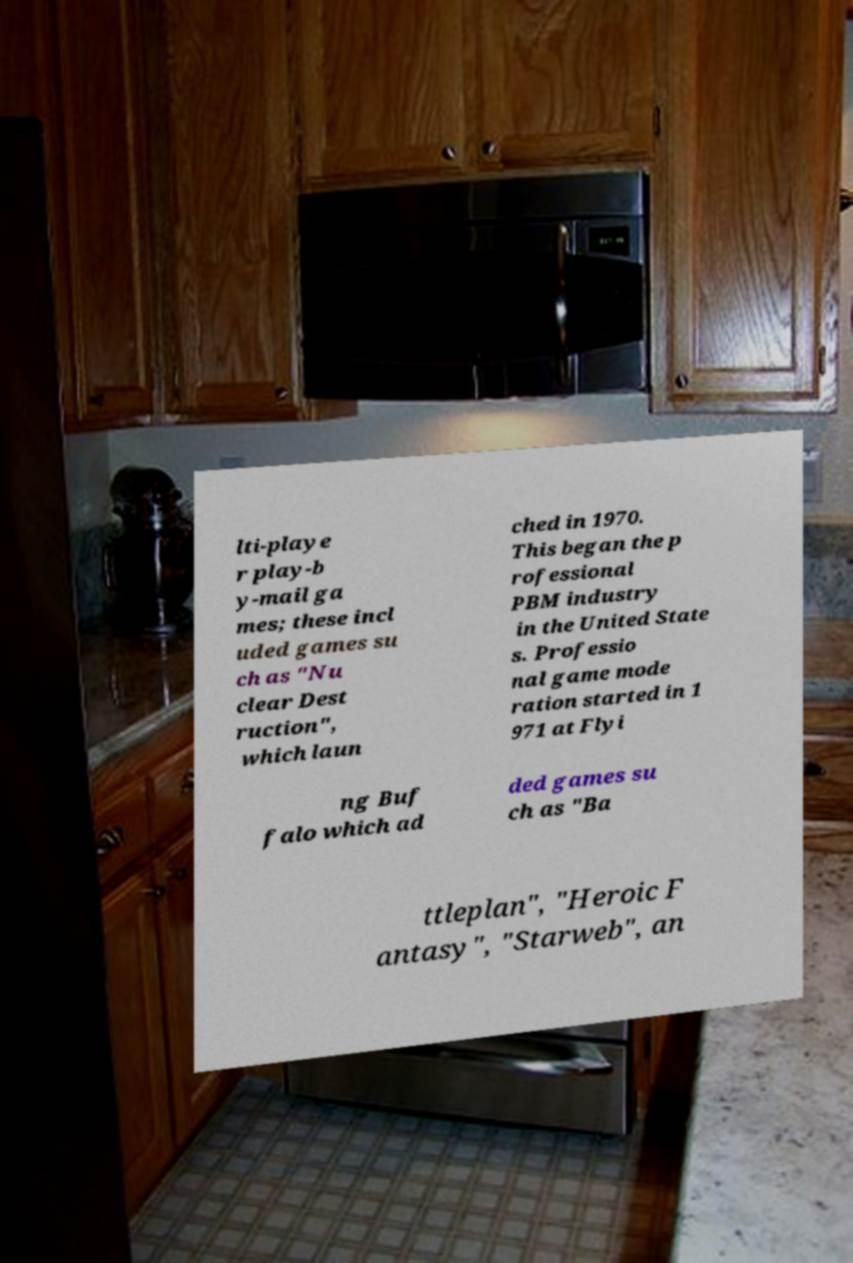Please read and relay the text visible in this image. What does it say? lti-playe r play-b y-mail ga mes; these incl uded games su ch as "Nu clear Dest ruction", which laun ched in 1970. This began the p rofessional PBM industry in the United State s. Professio nal game mode ration started in 1 971 at Flyi ng Buf falo which ad ded games su ch as "Ba ttleplan", "Heroic F antasy", "Starweb", an 